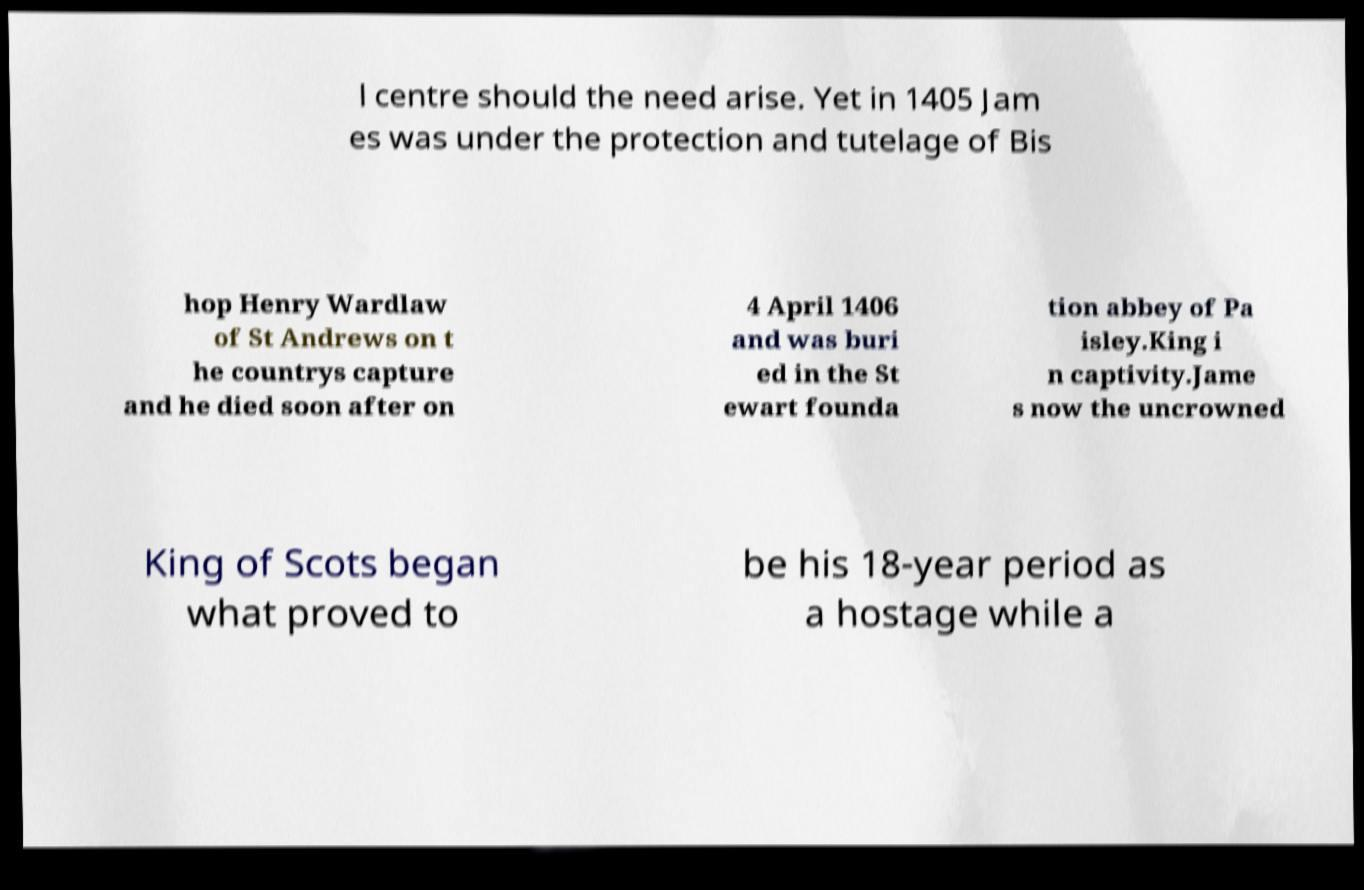Can you accurately transcribe the text from the provided image for me? l centre should the need arise. Yet in 1405 Jam es was under the protection and tutelage of Bis hop Henry Wardlaw of St Andrews on t he countrys capture and he died soon after on 4 April 1406 and was buri ed in the St ewart founda tion abbey of Pa isley.King i n captivity.Jame s now the uncrowned King of Scots began what proved to be his 18-year period as a hostage while a 